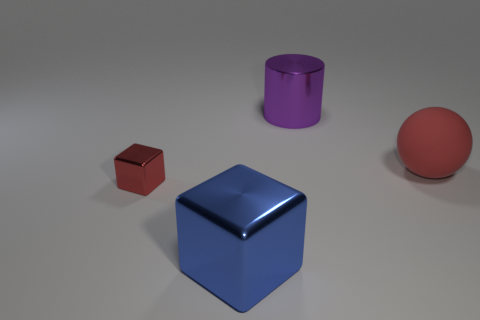Apart from the cubes, what other shapes can you identify in the image? Besides the cubes, the image features a sphere and a cylinder. The sphere is red and has a smooth surface, while the cylinder is purple with a matte finish. Explain how the light interacts with the objects in terms of shadow and reflection. The lighting in the image casts soft shadows from each object onto the ground, indicating a light source above or slightly to one side. The reflections on the objects, especially visible on the blue cube and the red sphere, suggest a glossy material that captures and slightly distorts the environmental light. These interactions enhance the three-dimensional feel of the scene. 